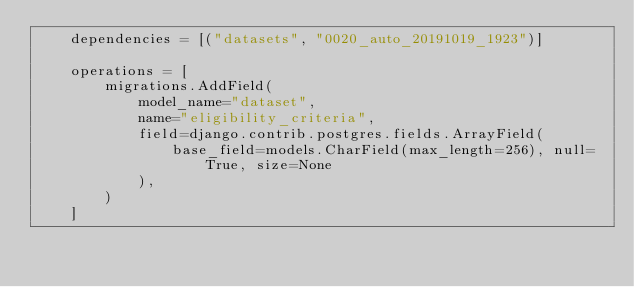Convert code to text. <code><loc_0><loc_0><loc_500><loc_500><_Python_>    dependencies = [("datasets", "0020_auto_20191019_1923")]

    operations = [
        migrations.AddField(
            model_name="dataset",
            name="eligibility_criteria",
            field=django.contrib.postgres.fields.ArrayField(
                base_field=models.CharField(max_length=256), null=True, size=None
            ),
        )
    ]
</code> 